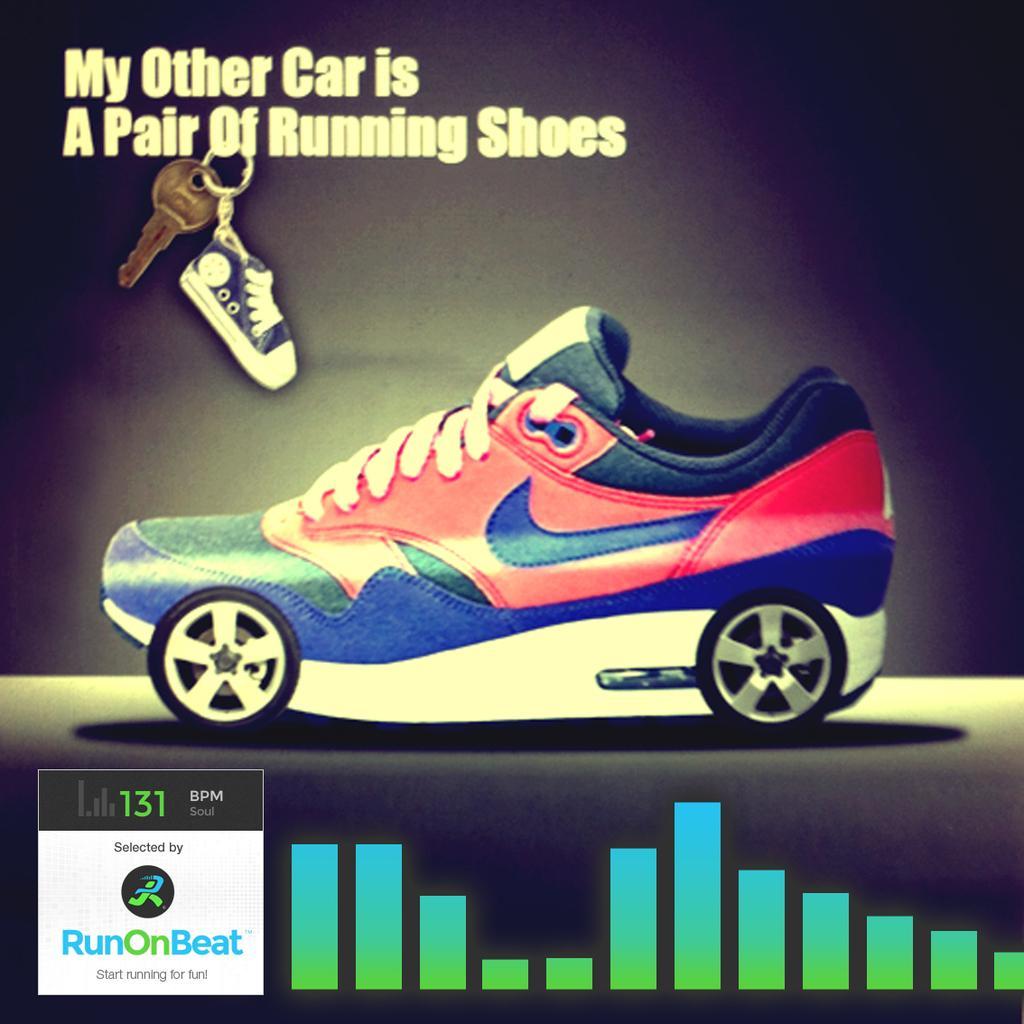Could you give a brief overview of what you see in this image? In this picture, it looks like a poster of a shoe and at the top of the shoe there is a key and a toy shoe. On the poster, it is written something and a logo. 